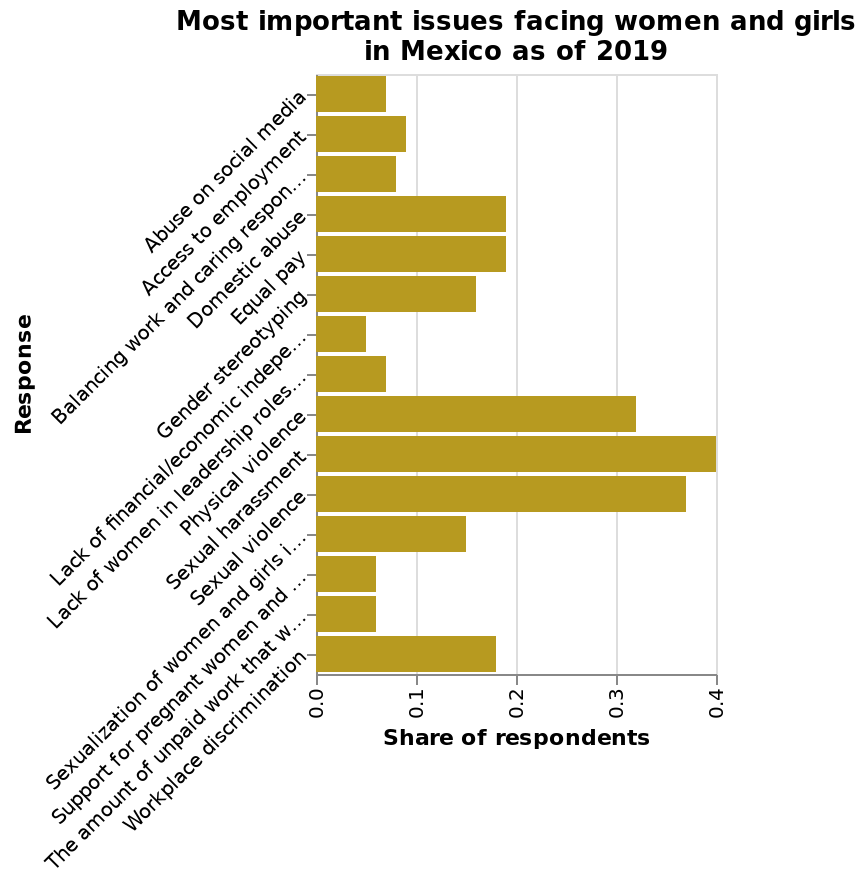<image>
please summary the statistics and relations of the chart Fifteen concerns are listed. The top concerns by highest share of respondents are Sexual Harassment, Sexual Violence, and Physical Violence, ranging from just over 0.3 for Physical Violence, and 0.4 for Sexual Harassment. The lowest three concerns are in the range of just under half of 0.1, to about half of 0.1. There's a large drop-off after the top three concerns, to just under 0.2 for Domestic Abuse, Equal Pay, and Workplace Discrimination. Other top concerns include Gender Stereotyping, Sexualization of Women & Girls I... (the listing cuts off), Access to Employment, and 6 others. please enumerates aspects of the construction of the chart Here a bar plot is labeled Most important issues facing women and girls in Mexico as of 2019. The x-axis shows Share of respondents while the y-axis measures Response. What does the x-axis represent in the bar plot? The x-axis in the bar plot represents the "Share of respondents". What are the top three concerns listed by the highest share of respondents?  The top three concerns listed by the highest share of respondents are Sexual Harassment, Sexual Violence, and Physical Violence. 